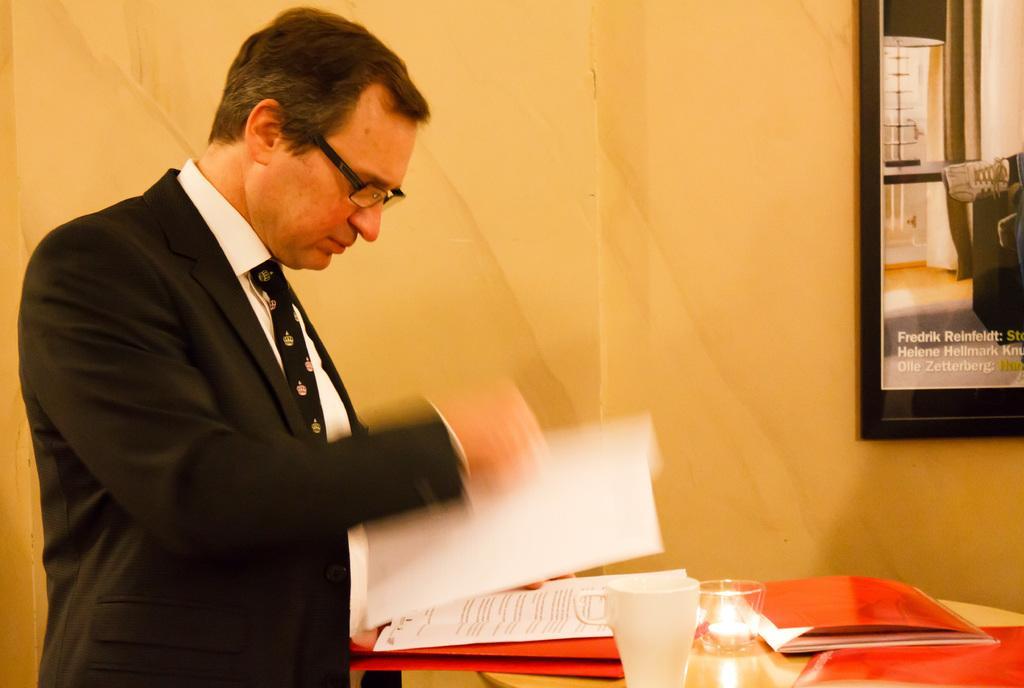Please provide a concise description of this image. In the image we can see there is a person who is standing and he is holding a paper in his hand and on the table there are papers, filed, glass. 